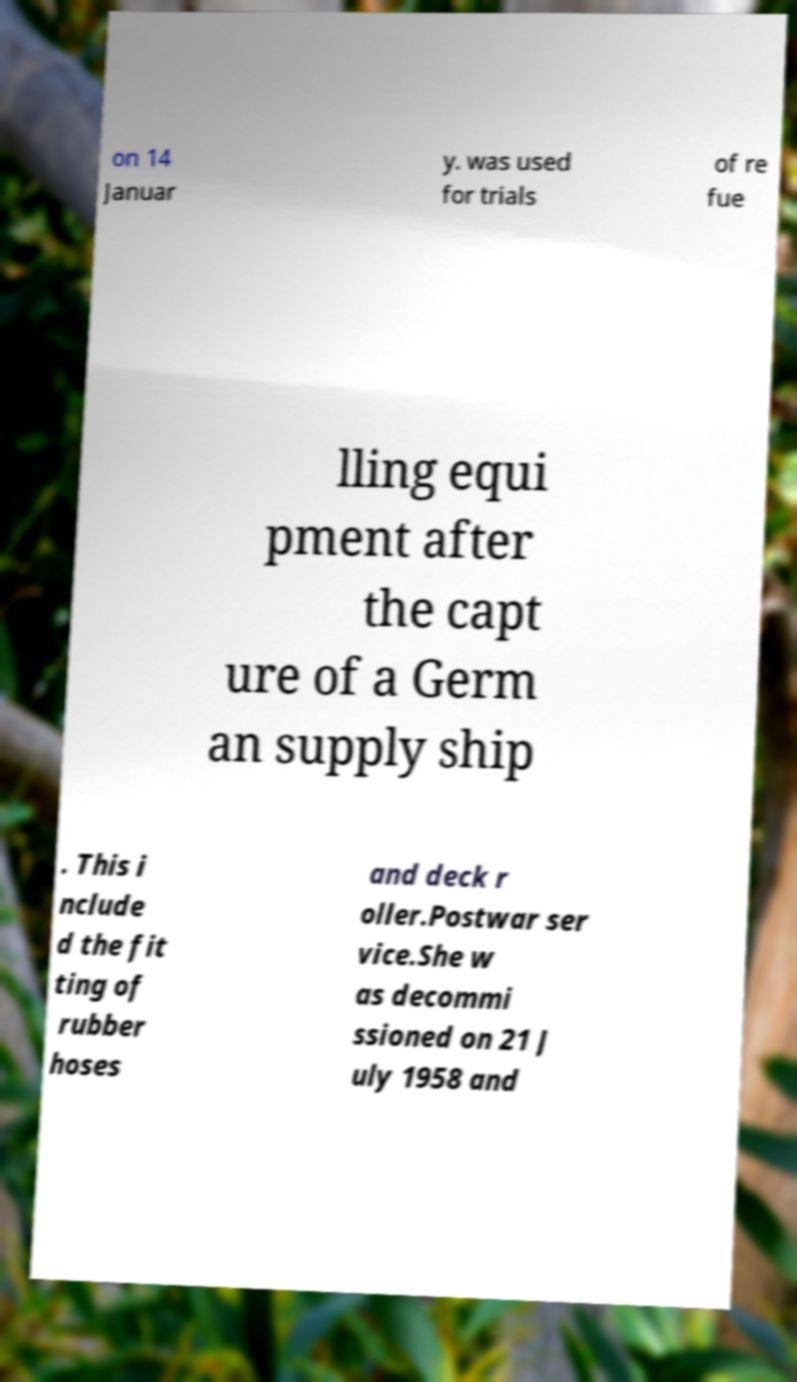For documentation purposes, I need the text within this image transcribed. Could you provide that? on 14 Januar y. was used for trials of re fue lling equi pment after the capt ure of a Germ an supply ship . This i nclude d the fit ting of rubber hoses and deck r oller.Postwar ser vice.She w as decommi ssioned on 21 J uly 1958 and 